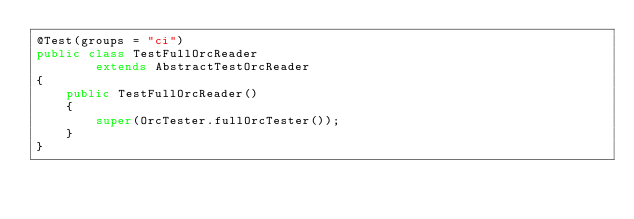<code> <loc_0><loc_0><loc_500><loc_500><_Java_>@Test(groups = "ci")
public class TestFullOrcReader
        extends AbstractTestOrcReader
{
    public TestFullOrcReader()
    {
        super(OrcTester.fullOrcTester());
    }
}
</code> 